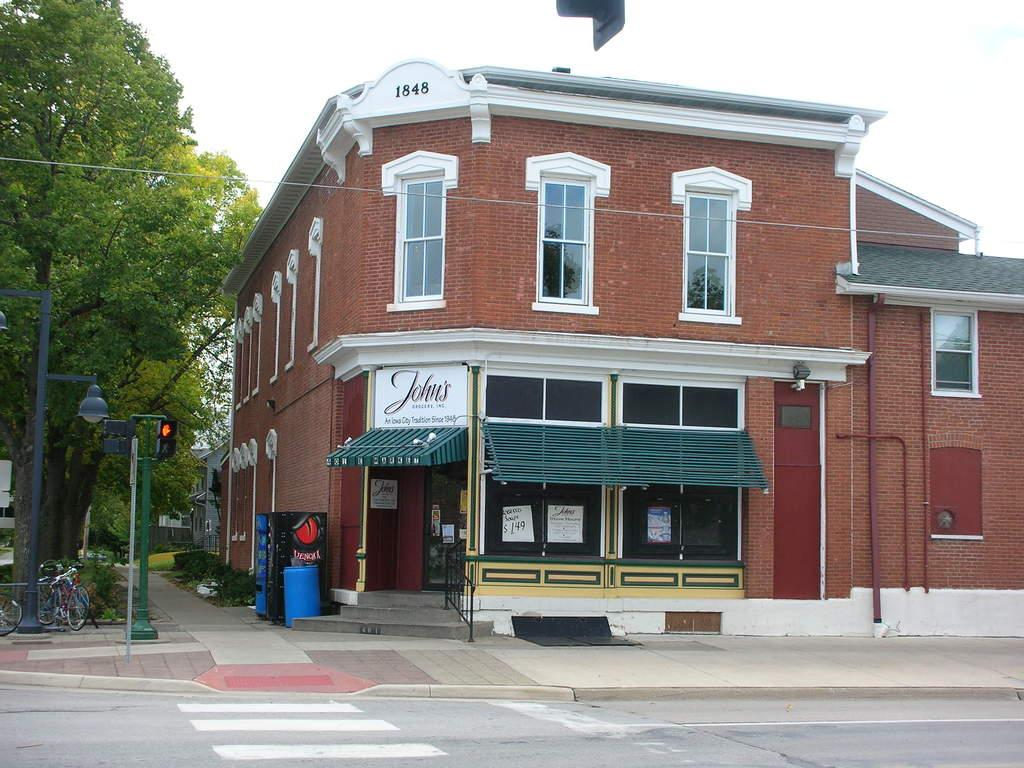What type of structure is present in the image? There is a building in the image. What feature can be observed on the building? The building has windows. What type of vegetation is present in the image? There are trees in the image. What type of pathway is visible in the image? There is a road in the image. What is visible in the background of the image? The sky is visible in the image. How many cows are grazing on the road in the image? There are no cows present in the image; it features a building, trees, a road, and the sky. What type of motion can be observed in the image? There is no motion depicted in the image; it is a still scene featuring a building, trees, a road, and the sky. 